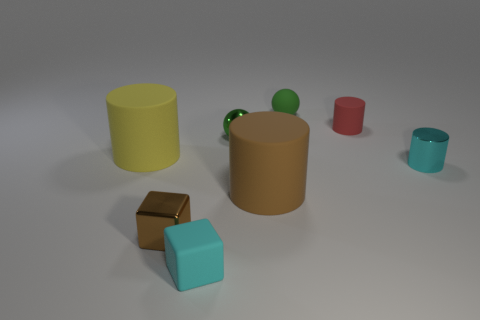There is a rubber object that is behind the big yellow cylinder and in front of the small green matte ball; what size is it?
Provide a succinct answer. Small. There is another object that is the same size as the yellow thing; what is it made of?
Your response must be concise. Rubber. There is a green thing in front of the tiny green sphere that is right of the green metal thing; what number of large matte things are on the right side of it?
Offer a very short reply. 1. Does the large rubber cylinder that is behind the large brown cylinder have the same color as the tiny thing on the left side of the cyan rubber cube?
Provide a short and direct response. No. There is a cylinder that is both behind the cyan cylinder and left of the rubber sphere; what is its color?
Offer a terse response. Yellow. How many cylinders have the same size as the cyan metal thing?
Provide a succinct answer. 1. What is the shape of the small cyan object that is behind the tiny block to the left of the tiny matte cube?
Keep it short and to the point. Cylinder. The metallic object that is to the left of the green thing on the left side of the brown object behind the brown metallic object is what shape?
Offer a terse response. Cube. How many other things are the same shape as the brown metal object?
Offer a terse response. 1. There is a green ball behind the small red rubber object; how many blocks are right of it?
Your answer should be compact. 0. 